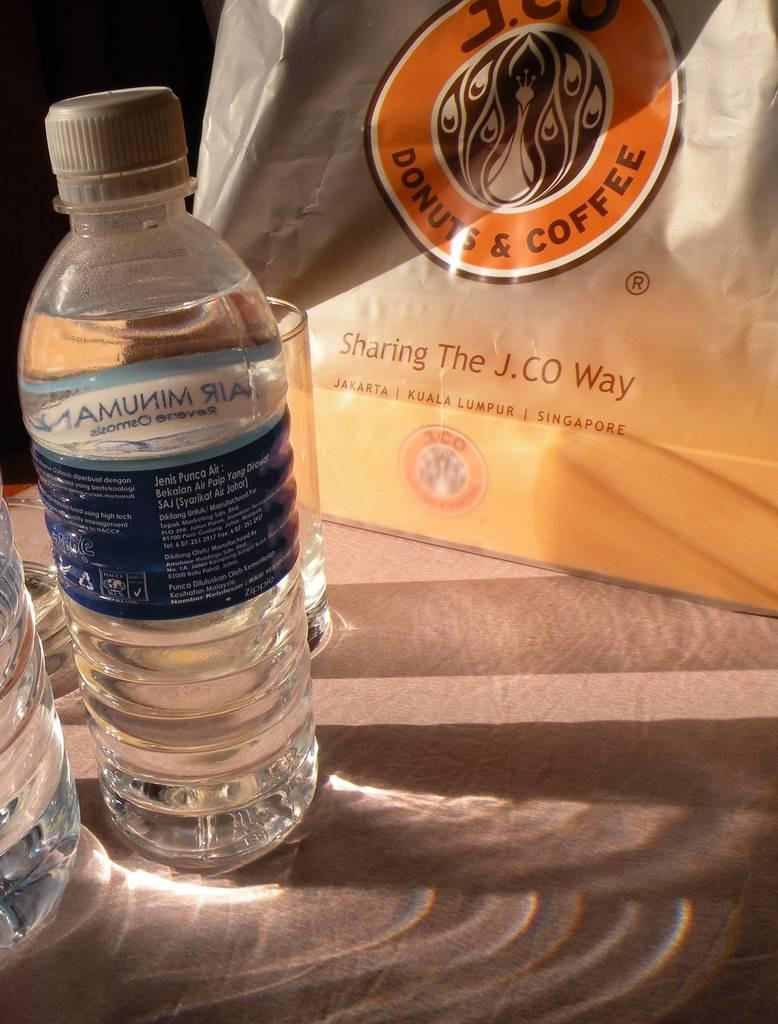<image>
Give a short and clear explanation of the subsequent image. A bag from J.CO Donuts & Coffee sits next to a water bottle 